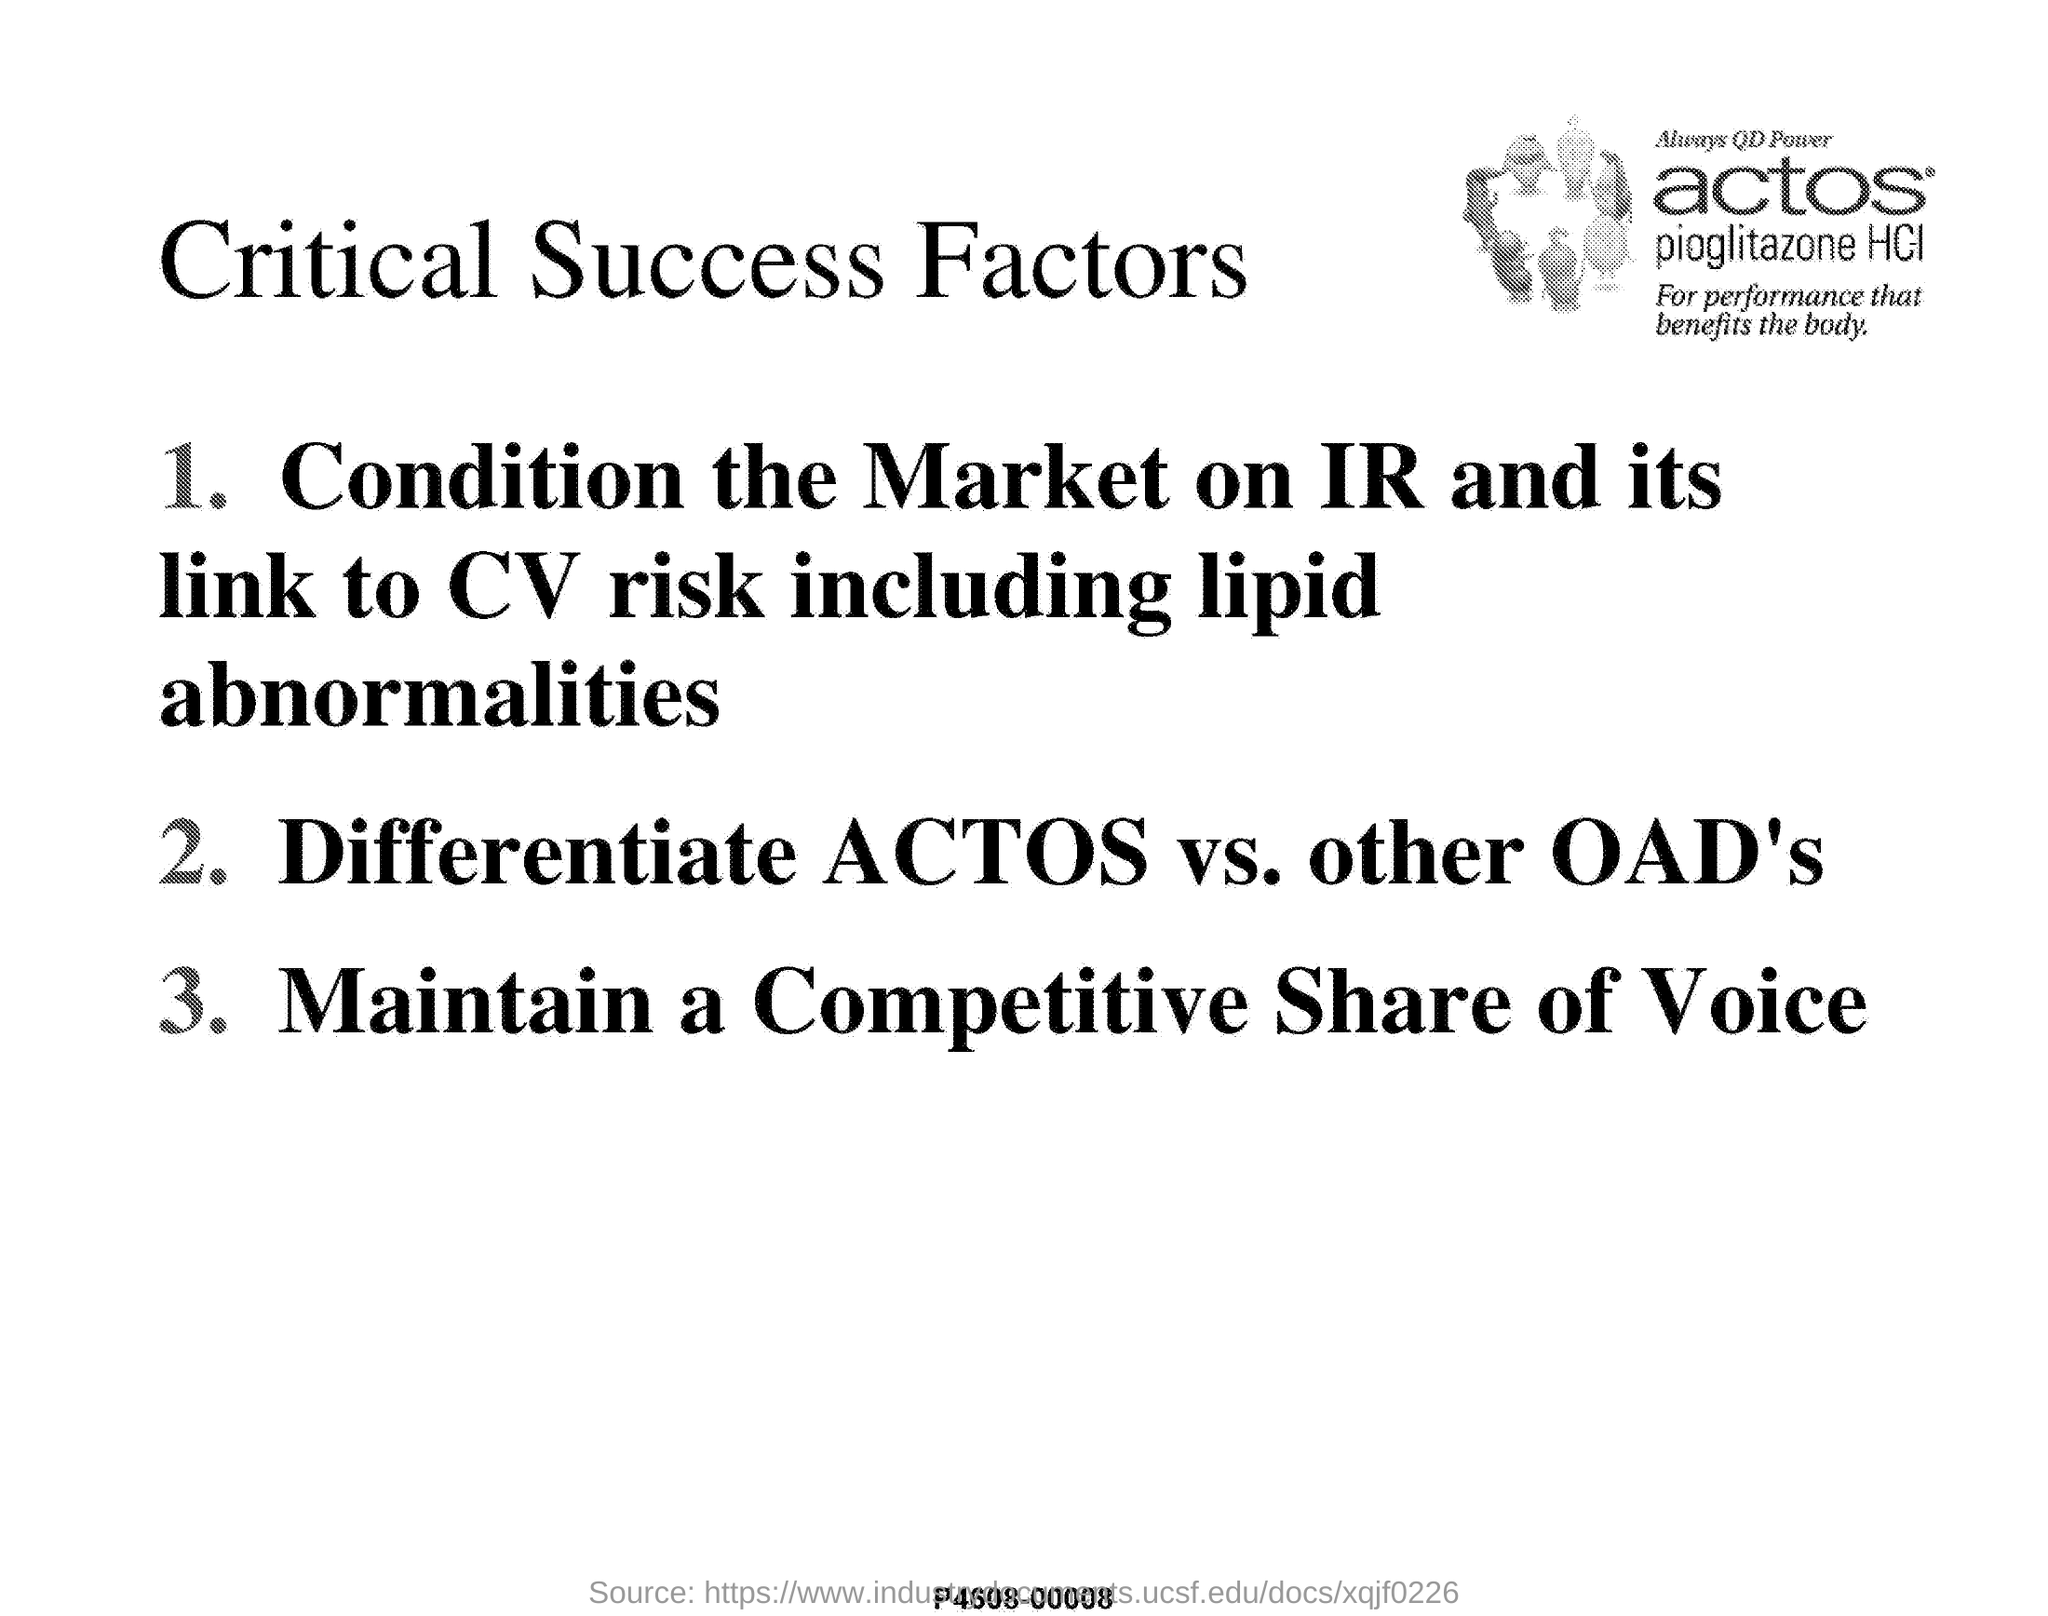Identify some key points in this picture. This document is titled 'Critical Success Factors'. 